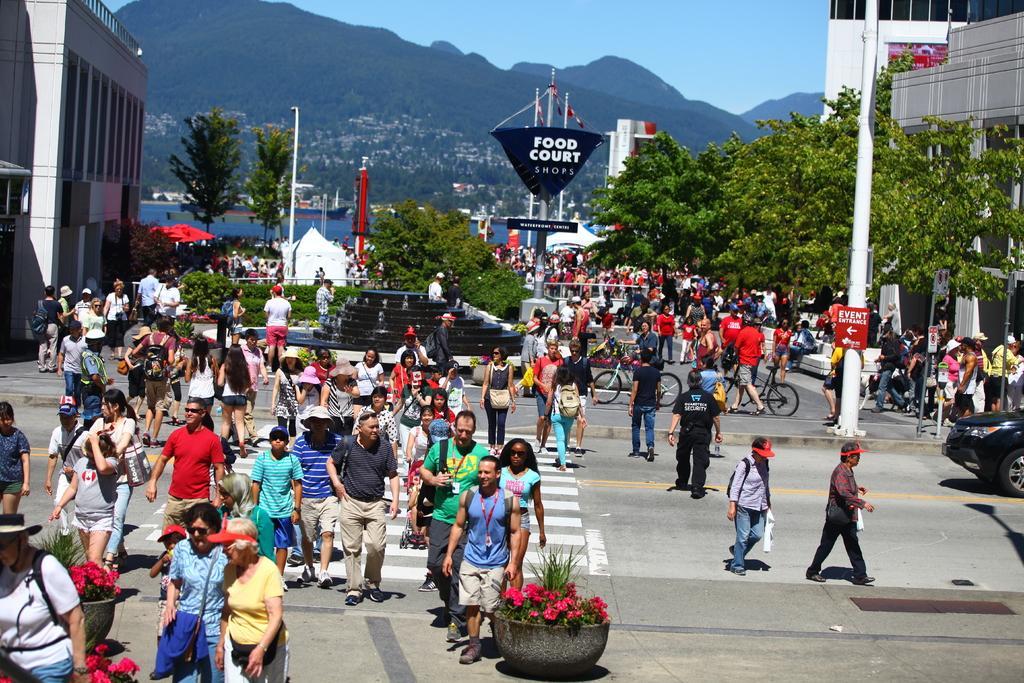Please provide a concise description of this image. In the picture I can see many people walking on the road, we can see flower pots, we can see some people are riding the bicycles, we can see vehicles moving on the road, we can see fountains, trees, boards, poles, buildings, ships floating on the water, we can see the hills and the sky in the background. 